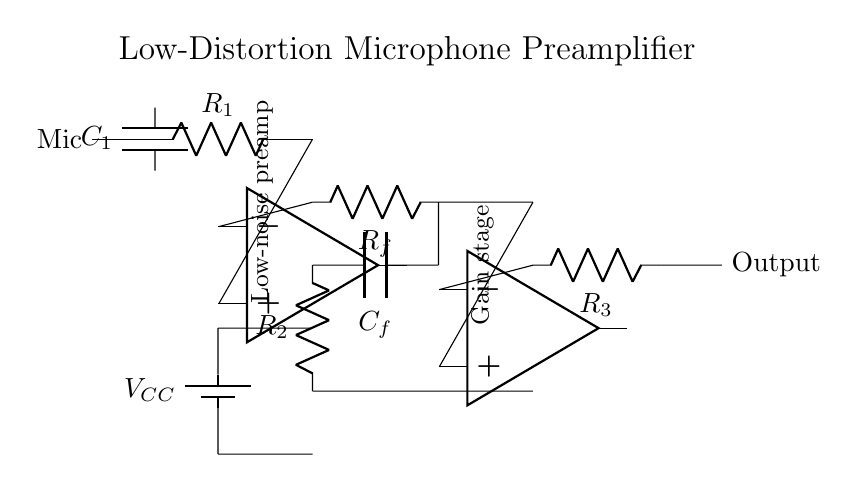What type of components are used in this circuit? The circuit diagram includes two operational amplifiers, resistors, and capacitors. These components are vital for amplifying the microphone signal while minimizing distortion.
Answer: operational amplifiers, resistors, capacitors What is the purpose of the capacitor labeled C1? Capacitor C1 is used to couple the microphone signal into the circuit while blocking any DC component, allowing only the AC audio signal to pass through.
Answer: coupling the microphone signal What is the gain configuration used in this preamplifier? The circuit employs a feedback resistor (R_f) and input resistor (R_2) to set the gain of the first operational amplifier, which is typical for non-inverting configurations.
Answer: non-inverting amplifier configuration How many amplification stages does this circuit have? Upon examining the diagram, it is evident that there are two operational amplifiers present, indicating two amplification stages in the design.
Answer: two What is the function of the battery labeled V_CC? The V_CC battery supplies the necessary power for the operational amplifiers to function, providing the energy required to amplify the audio signals effectively.
Answer: power supply for amplifiers What is the likely effect of using low-noise components in this design? The utilization of low-noise components significantly reduces interference and unwanted noise in the signal path, resulting in clearer and higher quality audio recordings.
Answer: reduces noise in audio recordings What role does the feedback capacitor C_f serve in the circuit? Capacitor C_f helps stabilize the gain and bandwidth of the operational amplifier by providing high-frequency roll-off, improving overall circuit performance.
Answer: stabilizes gain and bandwidth 